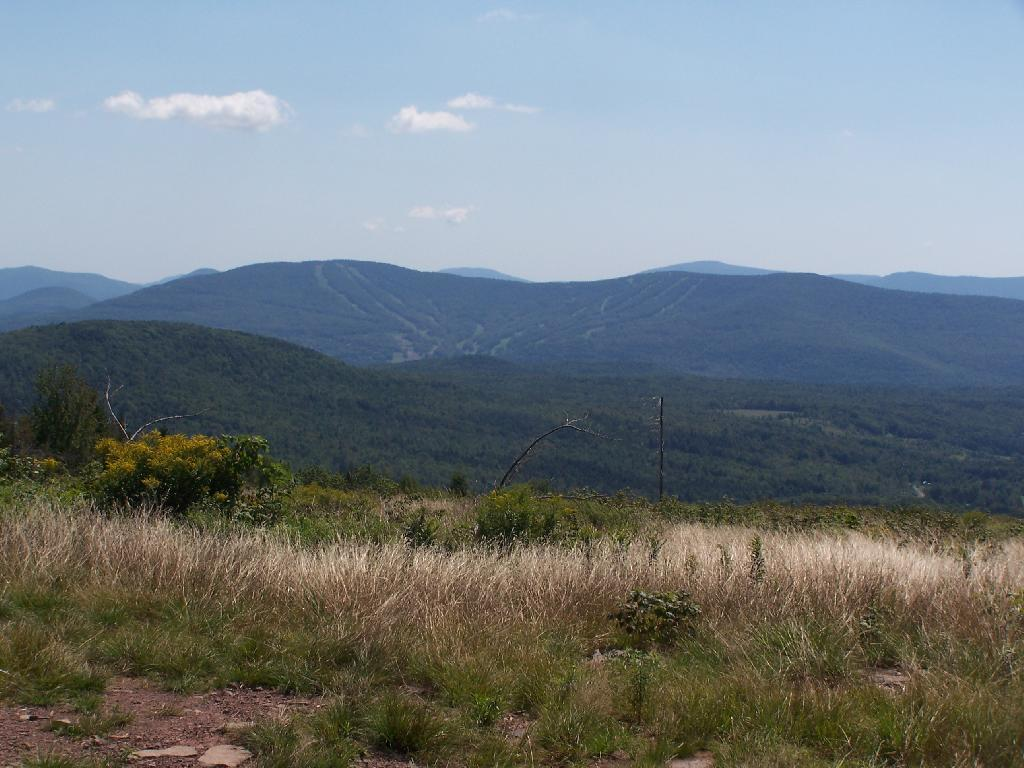What type of landscape can be seen in the image? There are hills in the image. What type of vegetation is present in the image? There are trees in the image. What is the ground covered with in the image? There is grass visible in the image. What is visible in the sky in the image? The sky is visible in the image, and there are clouds in the sky. What type of prose can be seen written on the hills in the image? There is no prose or writing visible on the hills in the image. What type of soda is being served in the image? There is no soda or any food or drink visible in the image. 